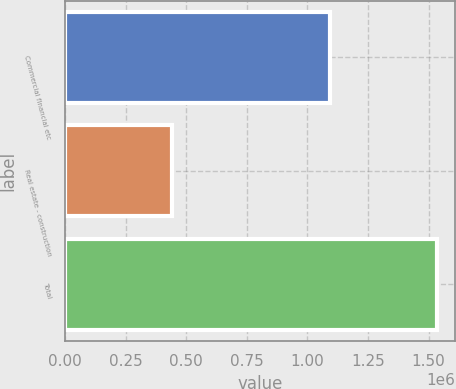<chart> <loc_0><loc_0><loc_500><loc_500><bar_chart><fcel>Commercial financial etc<fcel>Real estate - construction<fcel>Total<nl><fcel>1.09273e+06<fcel>439580<fcel>1.53231e+06<nl></chart> 